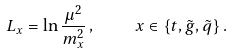Convert formula to latex. <formula><loc_0><loc_0><loc_500><loc_500>L _ { x } = \ln \frac { \mu ^ { 2 } } { m _ { x } ^ { 2 } } \, , \quad x \in \{ t , \tilde { g } , \tilde { q } \} \, .</formula> 